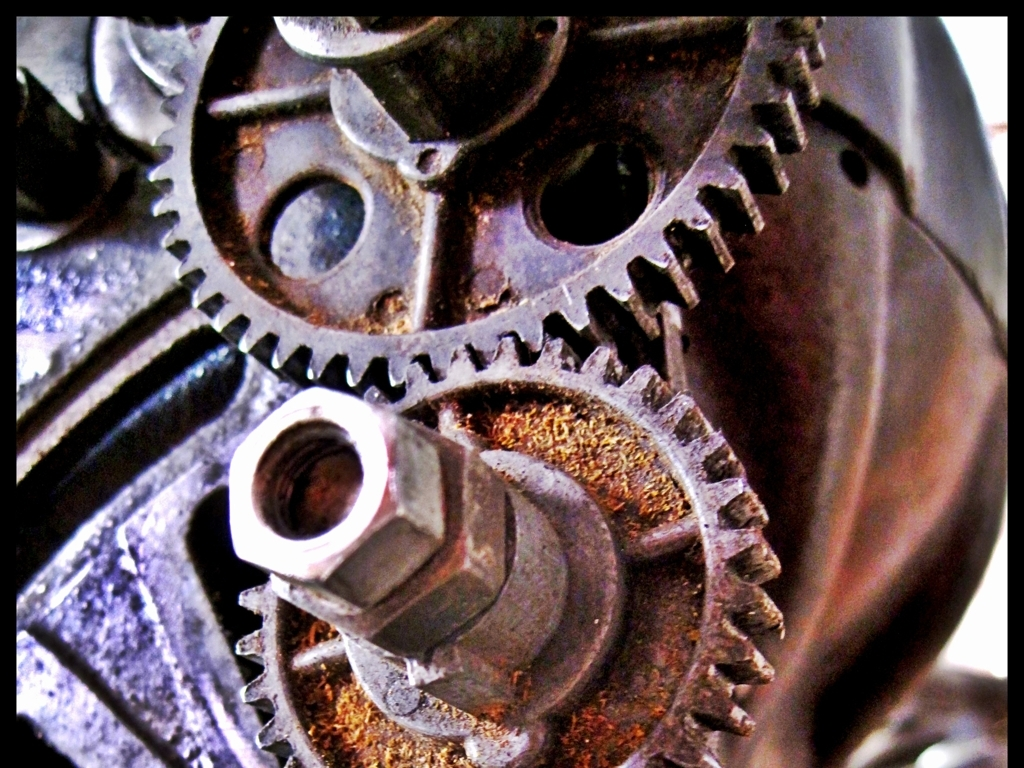Are there out-of-focus distortions in the image? Indeed, the photograph exhibits areas of soft focus, particularly noticeable around the edges of the frame and some of the gear teeth. This effect contributes to the image's depth, highlighting the intricate details and textures, and creating a sense of three-dimensionality. 